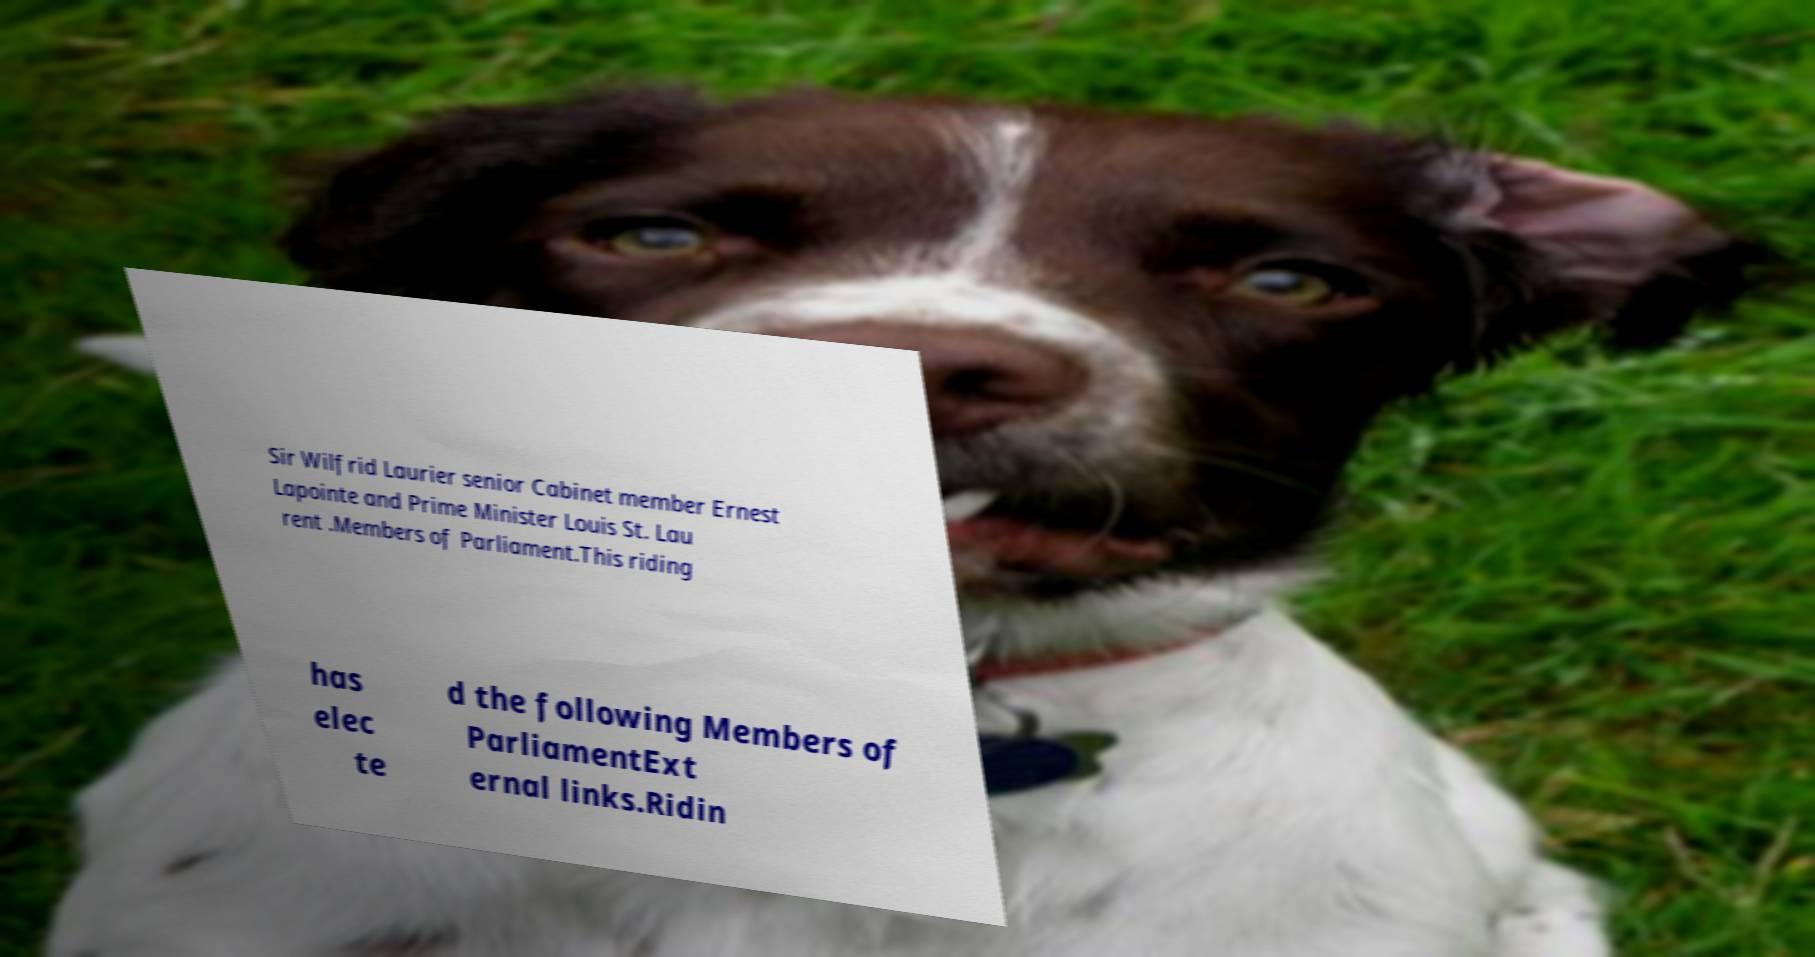For documentation purposes, I need the text within this image transcribed. Could you provide that? Sir Wilfrid Laurier senior Cabinet member Ernest Lapointe and Prime Minister Louis St. Lau rent .Members of Parliament.This riding has elec te d the following Members of ParliamentExt ernal links.Ridin 